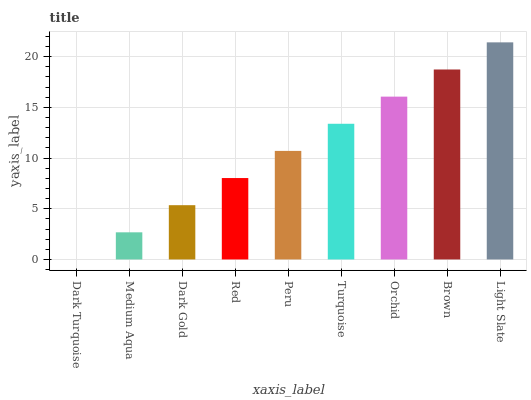Is Dark Turquoise the minimum?
Answer yes or no. Yes. Is Light Slate the maximum?
Answer yes or no. Yes. Is Medium Aqua the minimum?
Answer yes or no. No. Is Medium Aqua the maximum?
Answer yes or no. No. Is Medium Aqua greater than Dark Turquoise?
Answer yes or no. Yes. Is Dark Turquoise less than Medium Aqua?
Answer yes or no. Yes. Is Dark Turquoise greater than Medium Aqua?
Answer yes or no. No. Is Medium Aqua less than Dark Turquoise?
Answer yes or no. No. Is Peru the high median?
Answer yes or no. Yes. Is Peru the low median?
Answer yes or no. Yes. Is Light Slate the high median?
Answer yes or no. No. Is Red the low median?
Answer yes or no. No. 